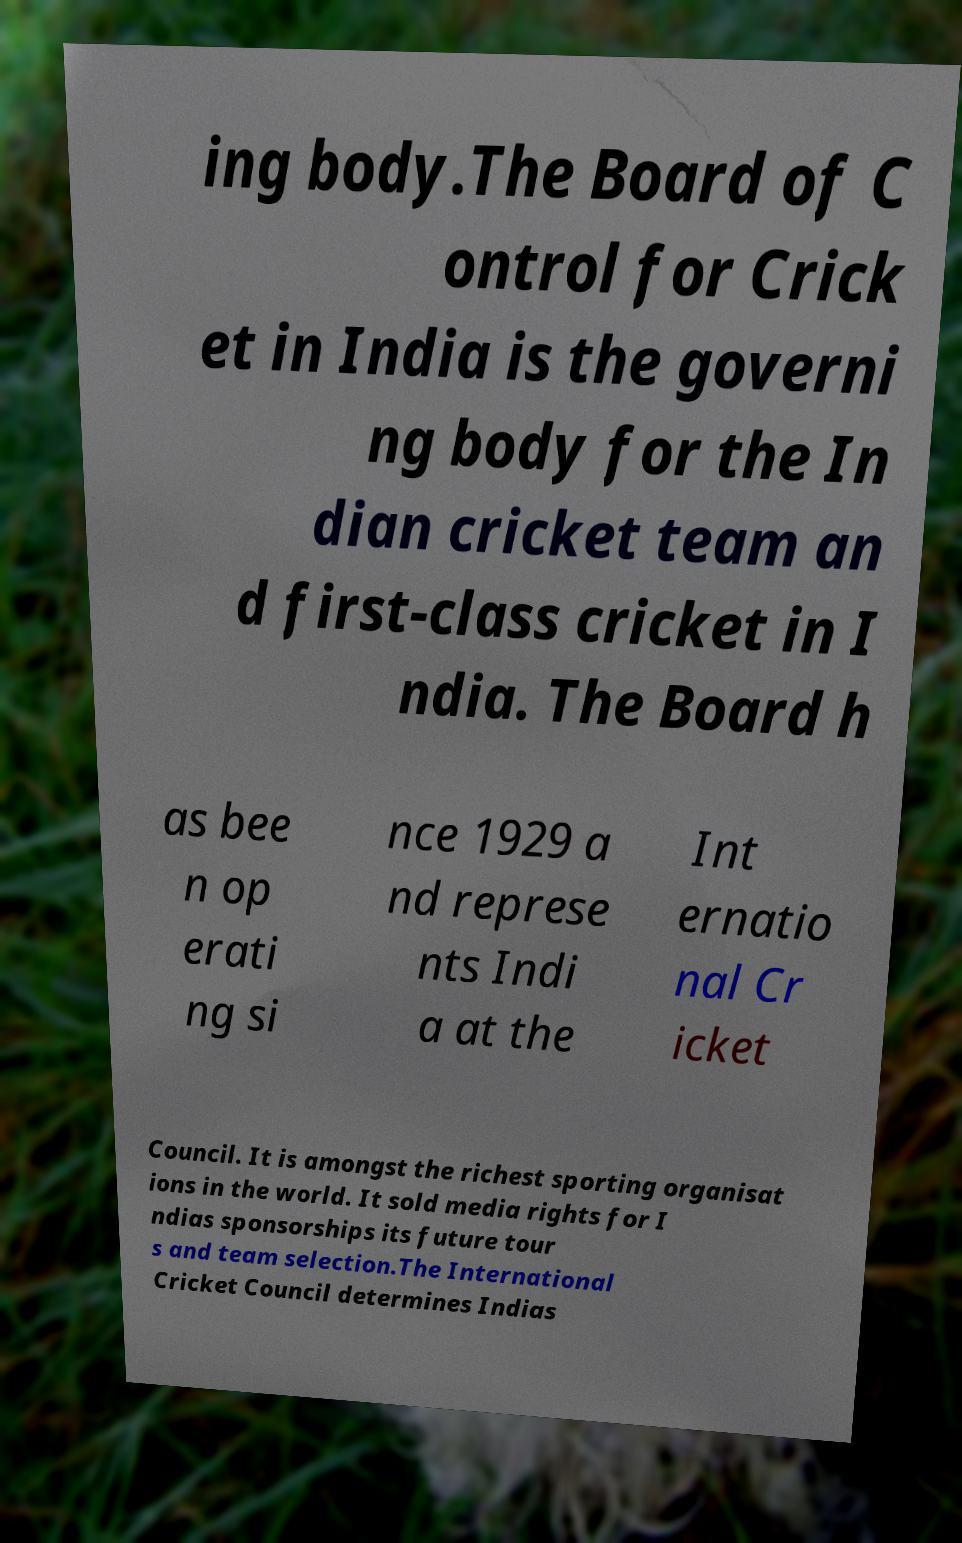Please read and relay the text visible in this image. What does it say? ing body.The Board of C ontrol for Crick et in India is the governi ng body for the In dian cricket team an d first-class cricket in I ndia. The Board h as bee n op erati ng si nce 1929 a nd represe nts Indi a at the Int ernatio nal Cr icket Council. It is amongst the richest sporting organisat ions in the world. It sold media rights for I ndias sponsorships its future tour s and team selection.The International Cricket Council determines Indias 